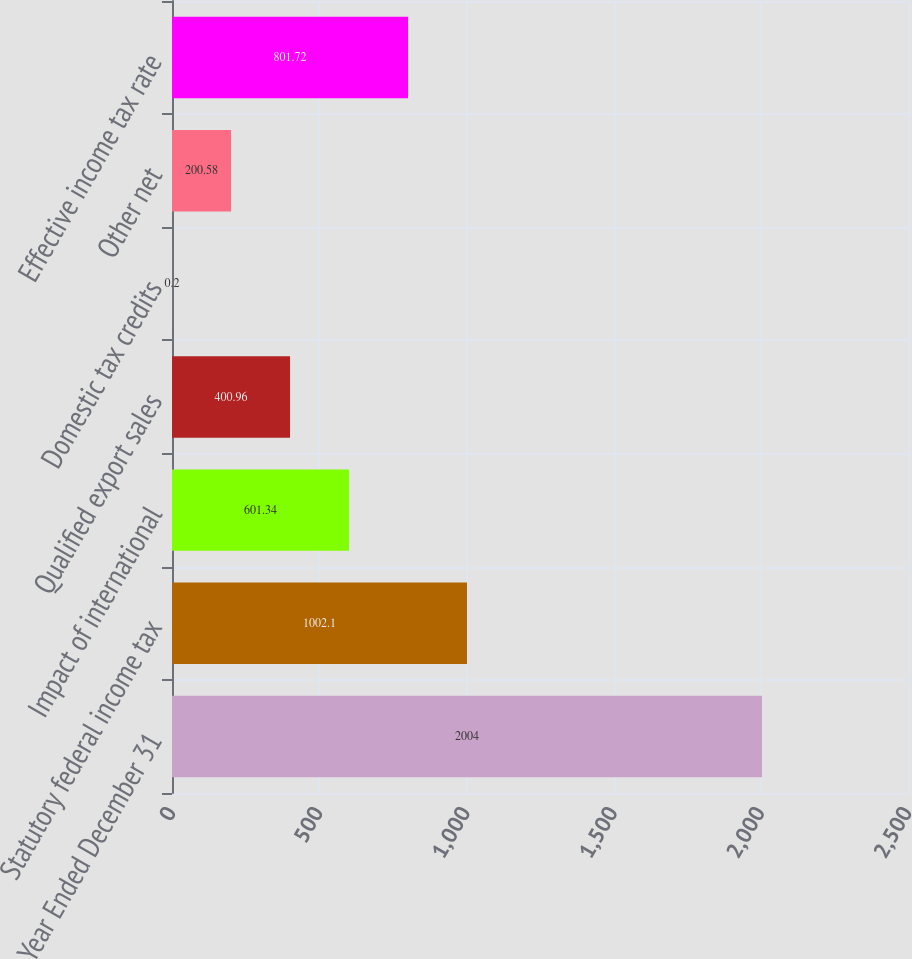Convert chart. <chart><loc_0><loc_0><loc_500><loc_500><bar_chart><fcel>Year Ended December 31<fcel>Statutory federal income tax<fcel>Impact of international<fcel>Qualified export sales<fcel>Domestic tax credits<fcel>Other net<fcel>Effective income tax rate<nl><fcel>2004<fcel>1002.1<fcel>601.34<fcel>400.96<fcel>0.2<fcel>200.58<fcel>801.72<nl></chart> 